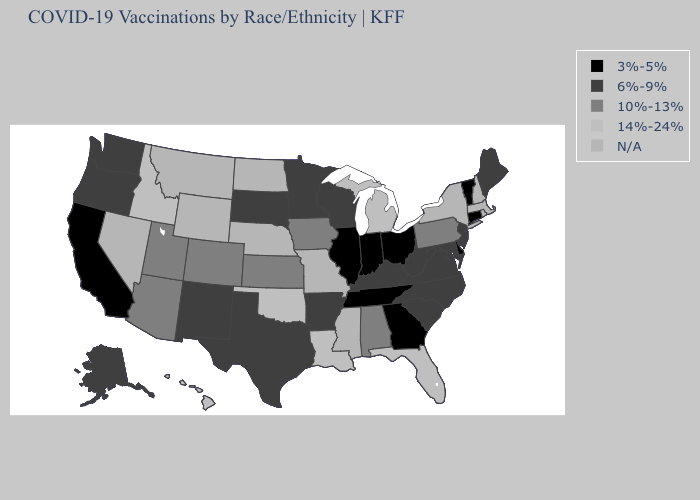Name the states that have a value in the range 10%-13%?
Quick response, please. Alabama, Arizona, Colorado, Iowa, Kansas, Pennsylvania, Utah. What is the value of California?
Be succinct. 3%-5%. Among the states that border Tennessee , which have the highest value?
Quick response, please. Alabama. What is the value of Pennsylvania?
Quick response, please. 10%-13%. Name the states that have a value in the range N/A?
Give a very brief answer. Massachusetts, Mississippi, Missouri, Montana, Nebraska, Nevada, New Hampshire, New York, North Dakota, Rhode Island, Wyoming. What is the value of Iowa?
Quick response, please. 10%-13%. Name the states that have a value in the range 14%-24%?
Concise answer only. Florida, Hawaii, Idaho, Louisiana, Michigan, Oklahoma. What is the value of Connecticut?
Write a very short answer. 3%-5%. What is the value of Ohio?
Answer briefly. 3%-5%. Is the legend a continuous bar?
Write a very short answer. No. What is the value of Hawaii?
Short answer required. 14%-24%. Which states hav the highest value in the South?
Concise answer only. Florida, Louisiana, Oklahoma. 